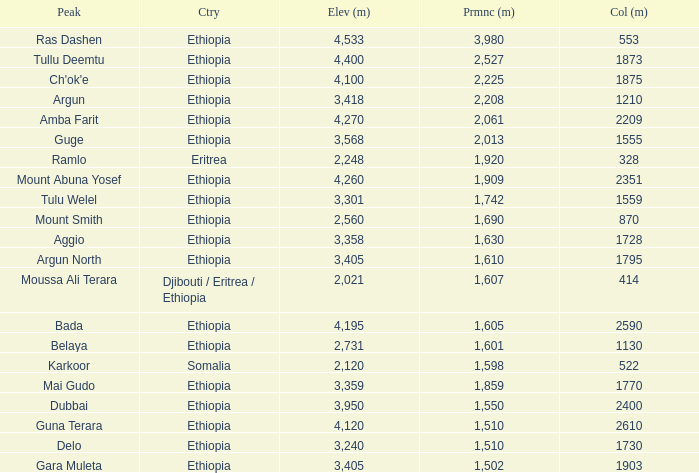What is the total prominence number in m of ethiopia, which has a col in m of 1728 and an elevation less than 3,358? 0.0. 